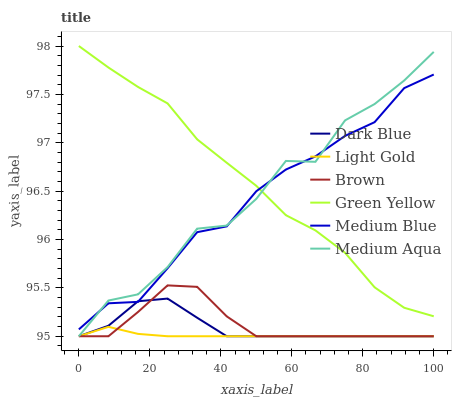Does Light Gold have the minimum area under the curve?
Answer yes or no. Yes. Does Green Yellow have the maximum area under the curve?
Answer yes or no. Yes. Does Medium Blue have the minimum area under the curve?
Answer yes or no. No. Does Medium Blue have the maximum area under the curve?
Answer yes or no. No. Is Light Gold the smoothest?
Answer yes or no. Yes. Is Medium Aqua the roughest?
Answer yes or no. Yes. Is Medium Blue the smoothest?
Answer yes or no. No. Is Medium Blue the roughest?
Answer yes or no. No. Does Brown have the lowest value?
Answer yes or no. Yes. Does Medium Blue have the lowest value?
Answer yes or no. No. Does Green Yellow have the highest value?
Answer yes or no. Yes. Does Medium Blue have the highest value?
Answer yes or no. No. Is Light Gold less than Green Yellow?
Answer yes or no. Yes. Is Green Yellow greater than Dark Blue?
Answer yes or no. Yes. Does Medium Aqua intersect Light Gold?
Answer yes or no. Yes. Is Medium Aqua less than Light Gold?
Answer yes or no. No. Is Medium Aqua greater than Light Gold?
Answer yes or no. No. Does Light Gold intersect Green Yellow?
Answer yes or no. No. 